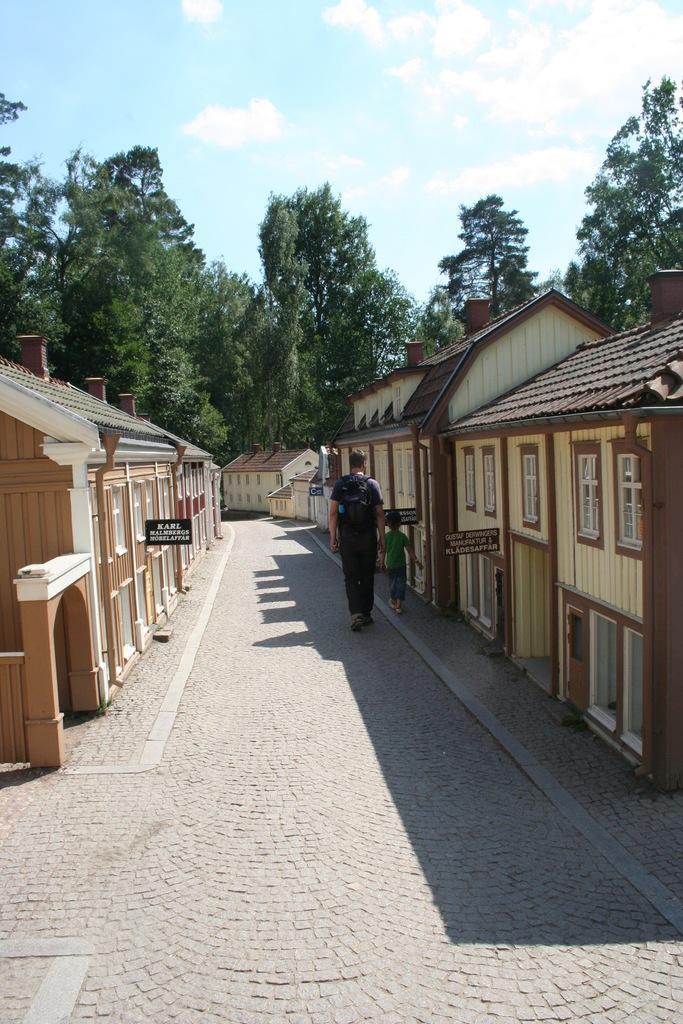Could you give a brief overview of what you see in this image? In the center of the image we can see persons on the road. On the right and left side of the image we can see houses. In the background we can see trees, sky and clouds. 